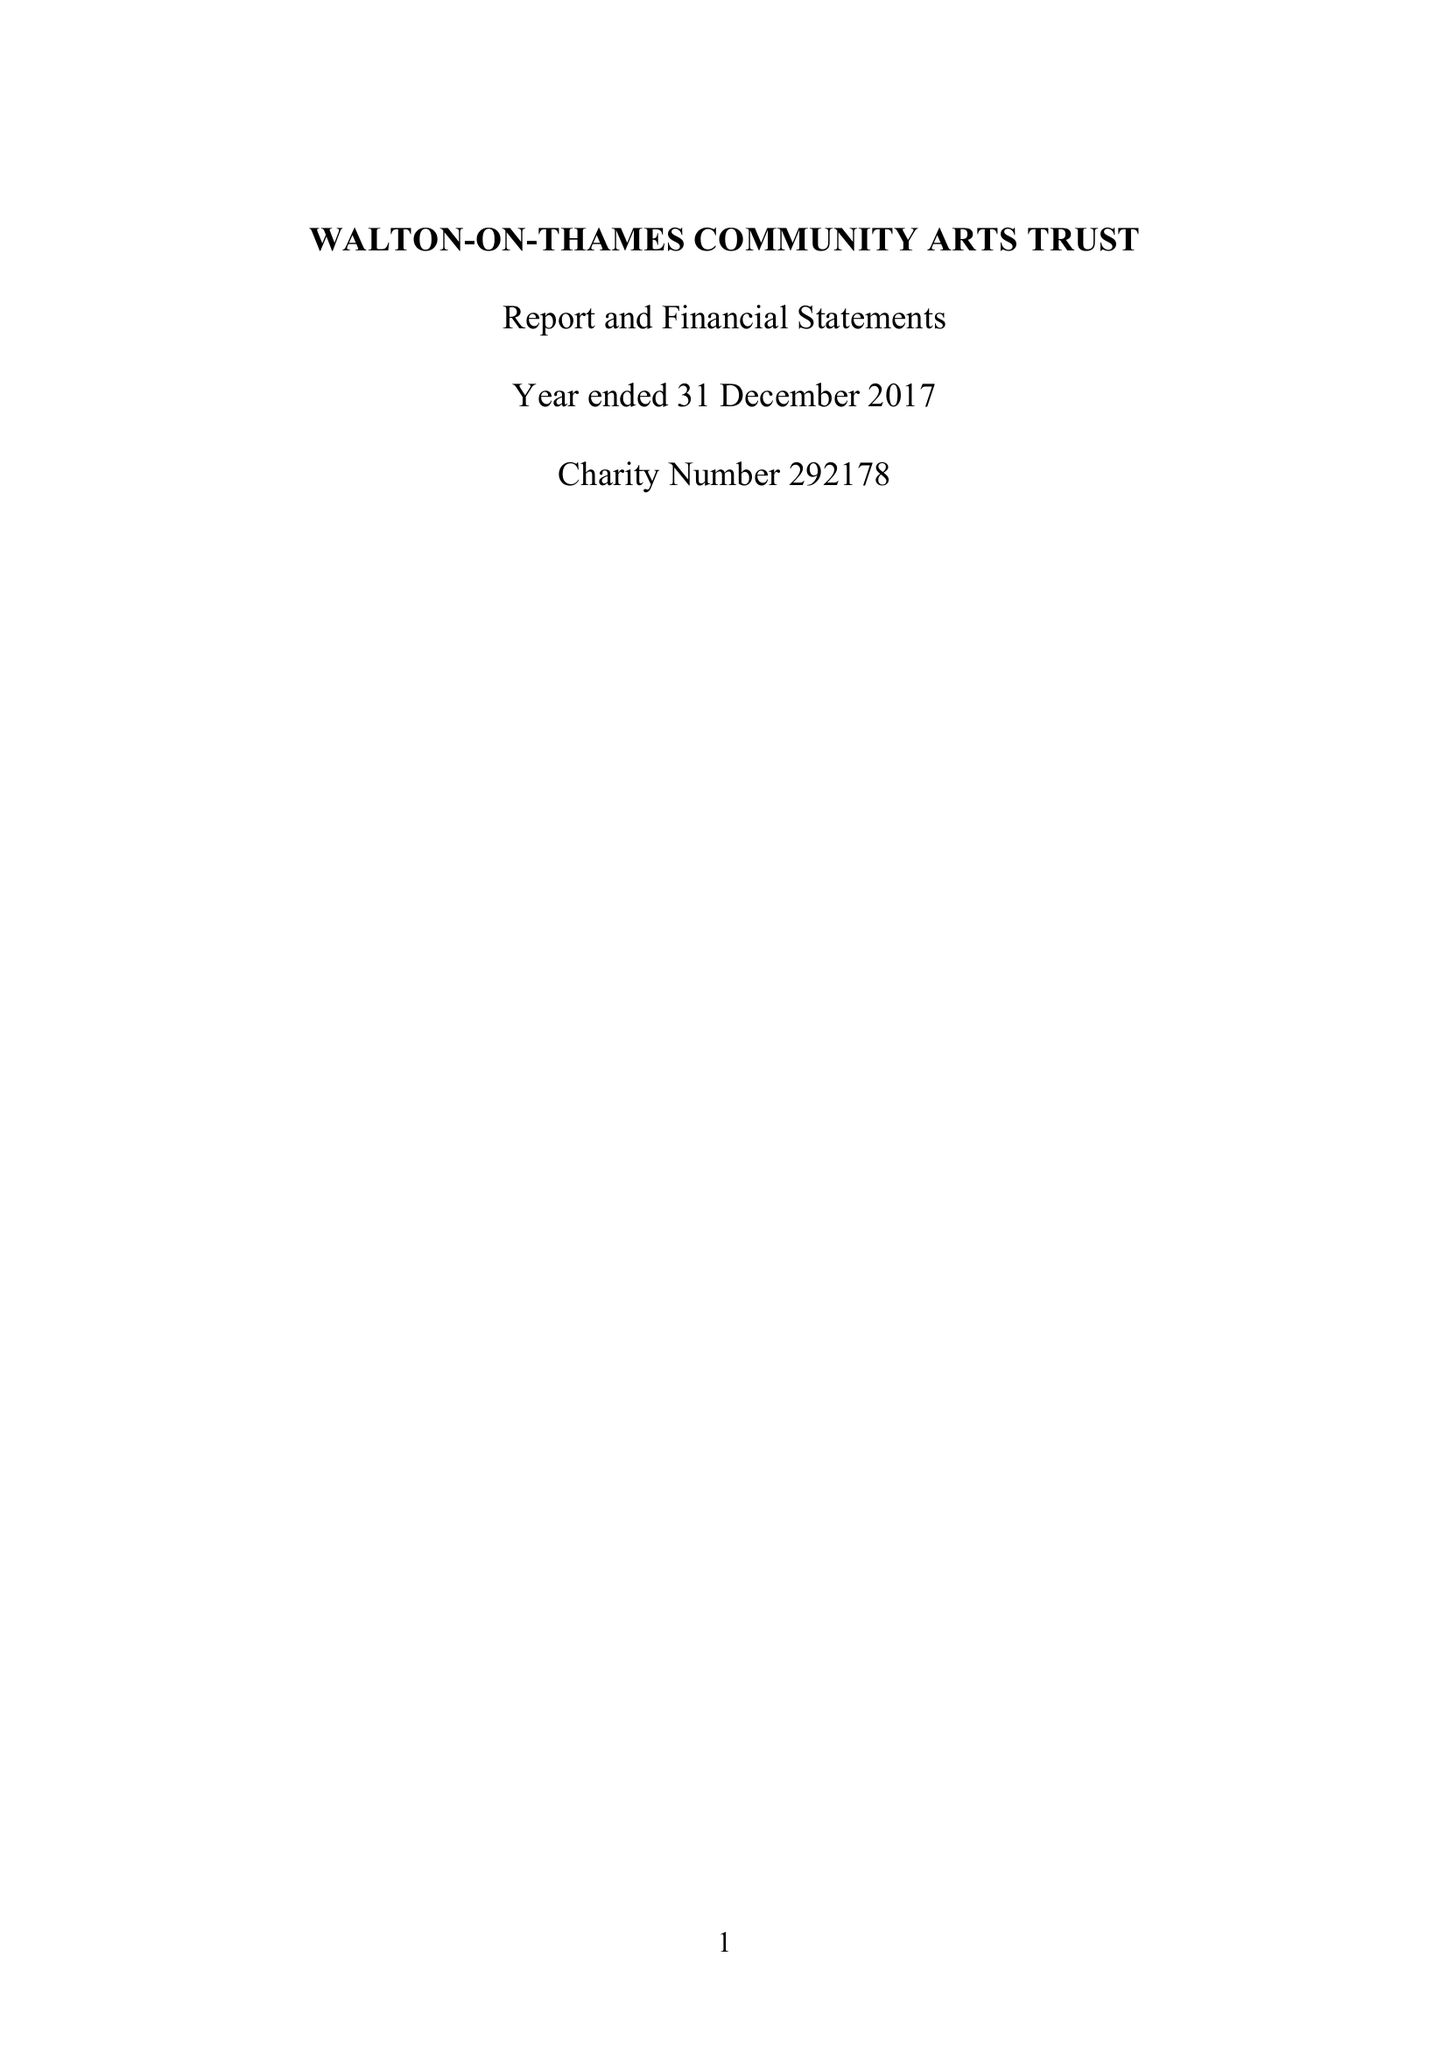What is the value for the income_annually_in_british_pounds?
Answer the question using a single word or phrase. 39506.00 